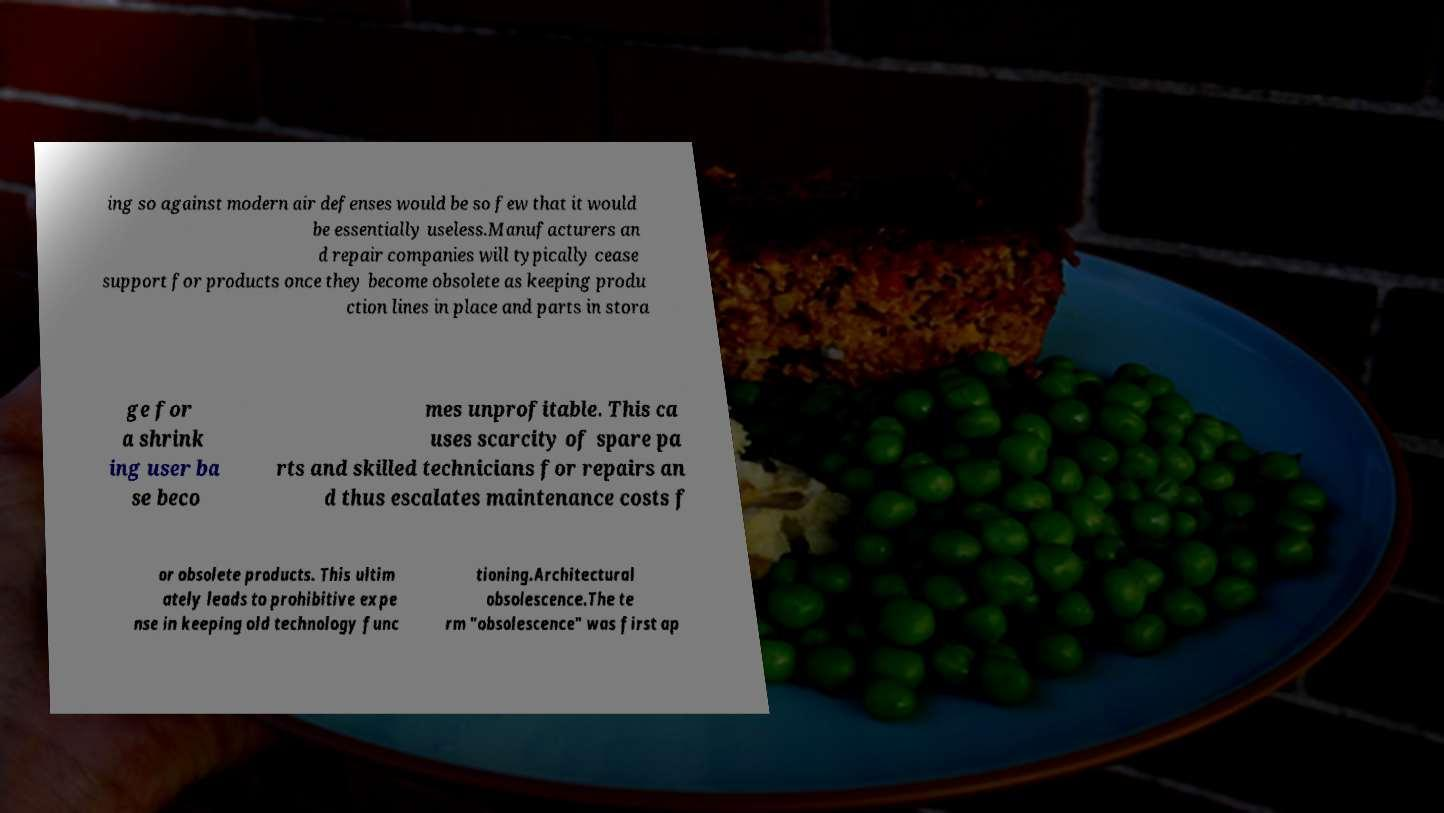What messages or text are displayed in this image? I need them in a readable, typed format. ing so against modern air defenses would be so few that it would be essentially useless.Manufacturers an d repair companies will typically cease support for products once they become obsolete as keeping produ ction lines in place and parts in stora ge for a shrink ing user ba se beco mes unprofitable. This ca uses scarcity of spare pa rts and skilled technicians for repairs an d thus escalates maintenance costs f or obsolete products. This ultim ately leads to prohibitive expe nse in keeping old technology func tioning.Architectural obsolescence.The te rm "obsolescence" was first ap 